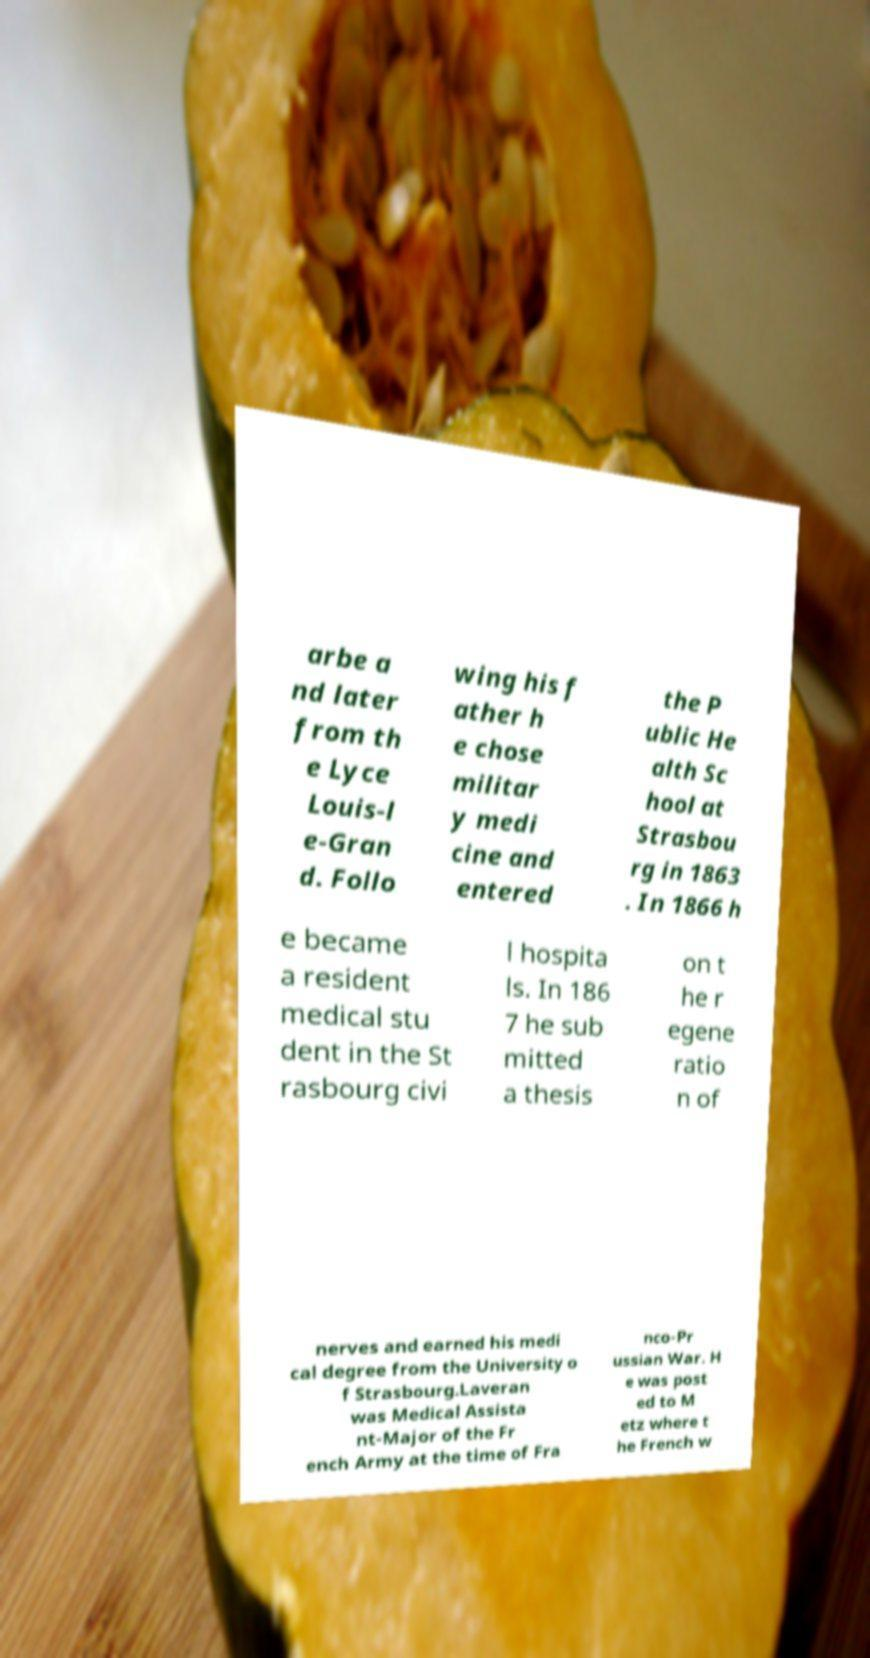What messages or text are displayed in this image? I need them in a readable, typed format. arbe a nd later from th e Lyce Louis-l e-Gran d. Follo wing his f ather h e chose militar y medi cine and entered the P ublic He alth Sc hool at Strasbou rg in 1863 . In 1866 h e became a resident medical stu dent in the St rasbourg civi l hospita ls. In 186 7 he sub mitted a thesis on t he r egene ratio n of nerves and earned his medi cal degree from the University o f Strasbourg.Laveran was Medical Assista nt-Major of the Fr ench Army at the time of Fra nco-Pr ussian War. H e was post ed to M etz where t he French w 